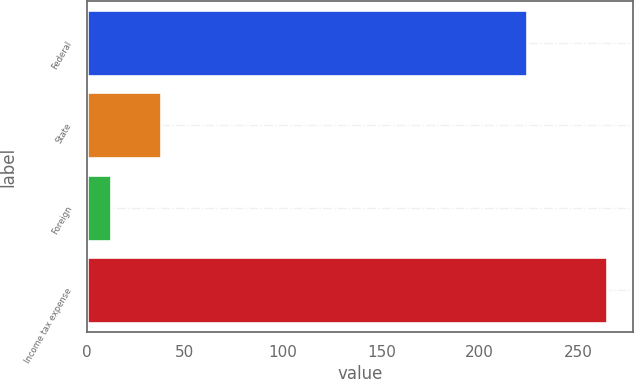<chart> <loc_0><loc_0><loc_500><loc_500><bar_chart><fcel>Federal<fcel>State<fcel>Foreign<fcel>Income tax expense<nl><fcel>223.9<fcel>37.81<fcel>12.6<fcel>264.7<nl></chart> 